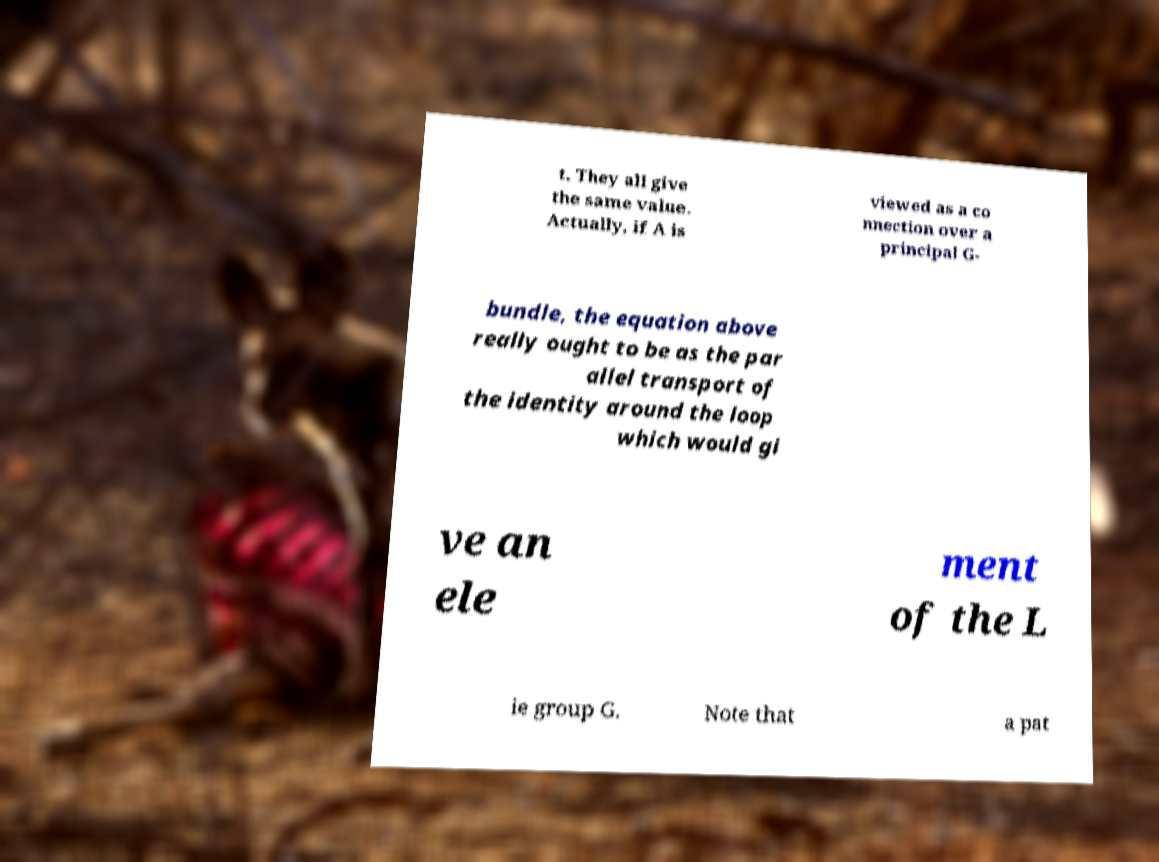For documentation purposes, I need the text within this image transcribed. Could you provide that? t. They all give the same value. Actually, if A is viewed as a co nnection over a principal G- bundle, the equation above really ought to be as the par allel transport of the identity around the loop which would gi ve an ele ment of the L ie group G. Note that a pat 